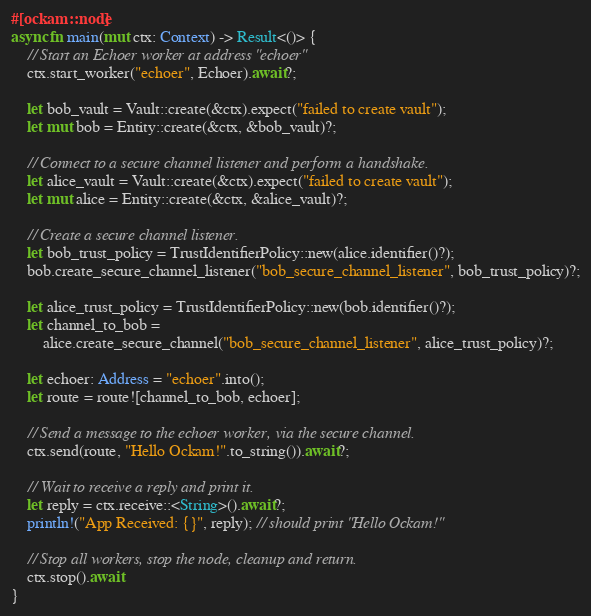Convert code to text. <code><loc_0><loc_0><loc_500><loc_500><_Rust_>#[ockam::node]
async fn main(mut ctx: Context) -> Result<()> {
    // Start an Echoer worker at address "echoer"
    ctx.start_worker("echoer", Echoer).await?;

    let bob_vault = Vault::create(&ctx).expect("failed to create vault");
    let mut bob = Entity::create(&ctx, &bob_vault)?;

    // Connect to a secure channel listener and perform a handshake.
    let alice_vault = Vault::create(&ctx).expect("failed to create vault");
    let mut alice = Entity::create(&ctx, &alice_vault)?;

    // Create a secure channel listener.
    let bob_trust_policy = TrustIdentifierPolicy::new(alice.identifier()?);
    bob.create_secure_channel_listener("bob_secure_channel_listener", bob_trust_policy)?;

    let alice_trust_policy = TrustIdentifierPolicy::new(bob.identifier()?);
    let channel_to_bob =
        alice.create_secure_channel("bob_secure_channel_listener", alice_trust_policy)?;

    let echoer: Address = "echoer".into();
    let route = route![channel_to_bob, echoer];

    // Send a message to the echoer worker, via the secure channel.
    ctx.send(route, "Hello Ockam!".to_string()).await?;

    // Wait to receive a reply and print it.
    let reply = ctx.receive::<String>().await?;
    println!("App Received: {}", reply); // should print "Hello Ockam!"

    // Stop all workers, stop the node, cleanup and return.
    ctx.stop().await
}
</code> 